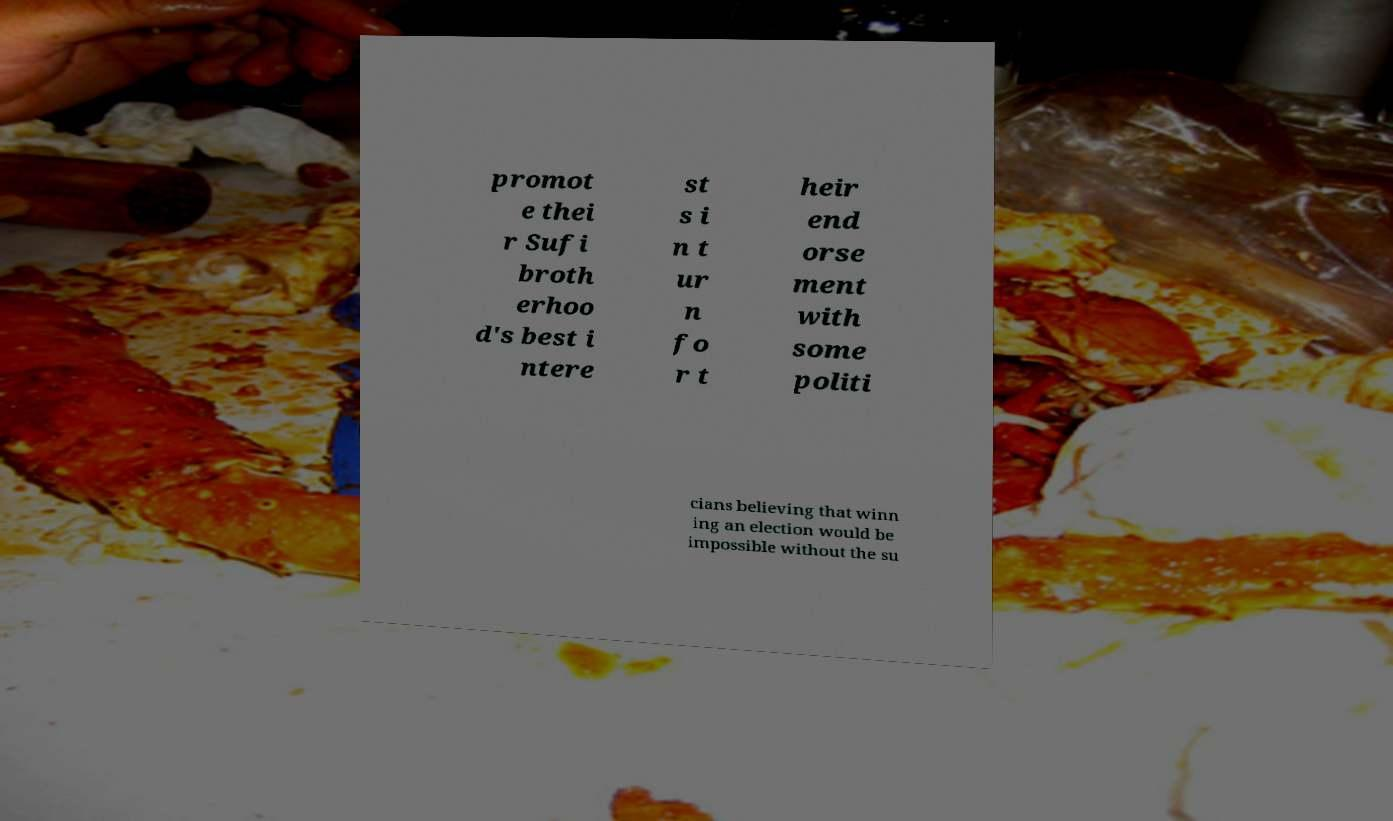Could you assist in decoding the text presented in this image and type it out clearly? promot e thei r Sufi broth erhoo d's best i ntere st s i n t ur n fo r t heir end orse ment with some politi cians believing that winn ing an election would be impossible without the su 